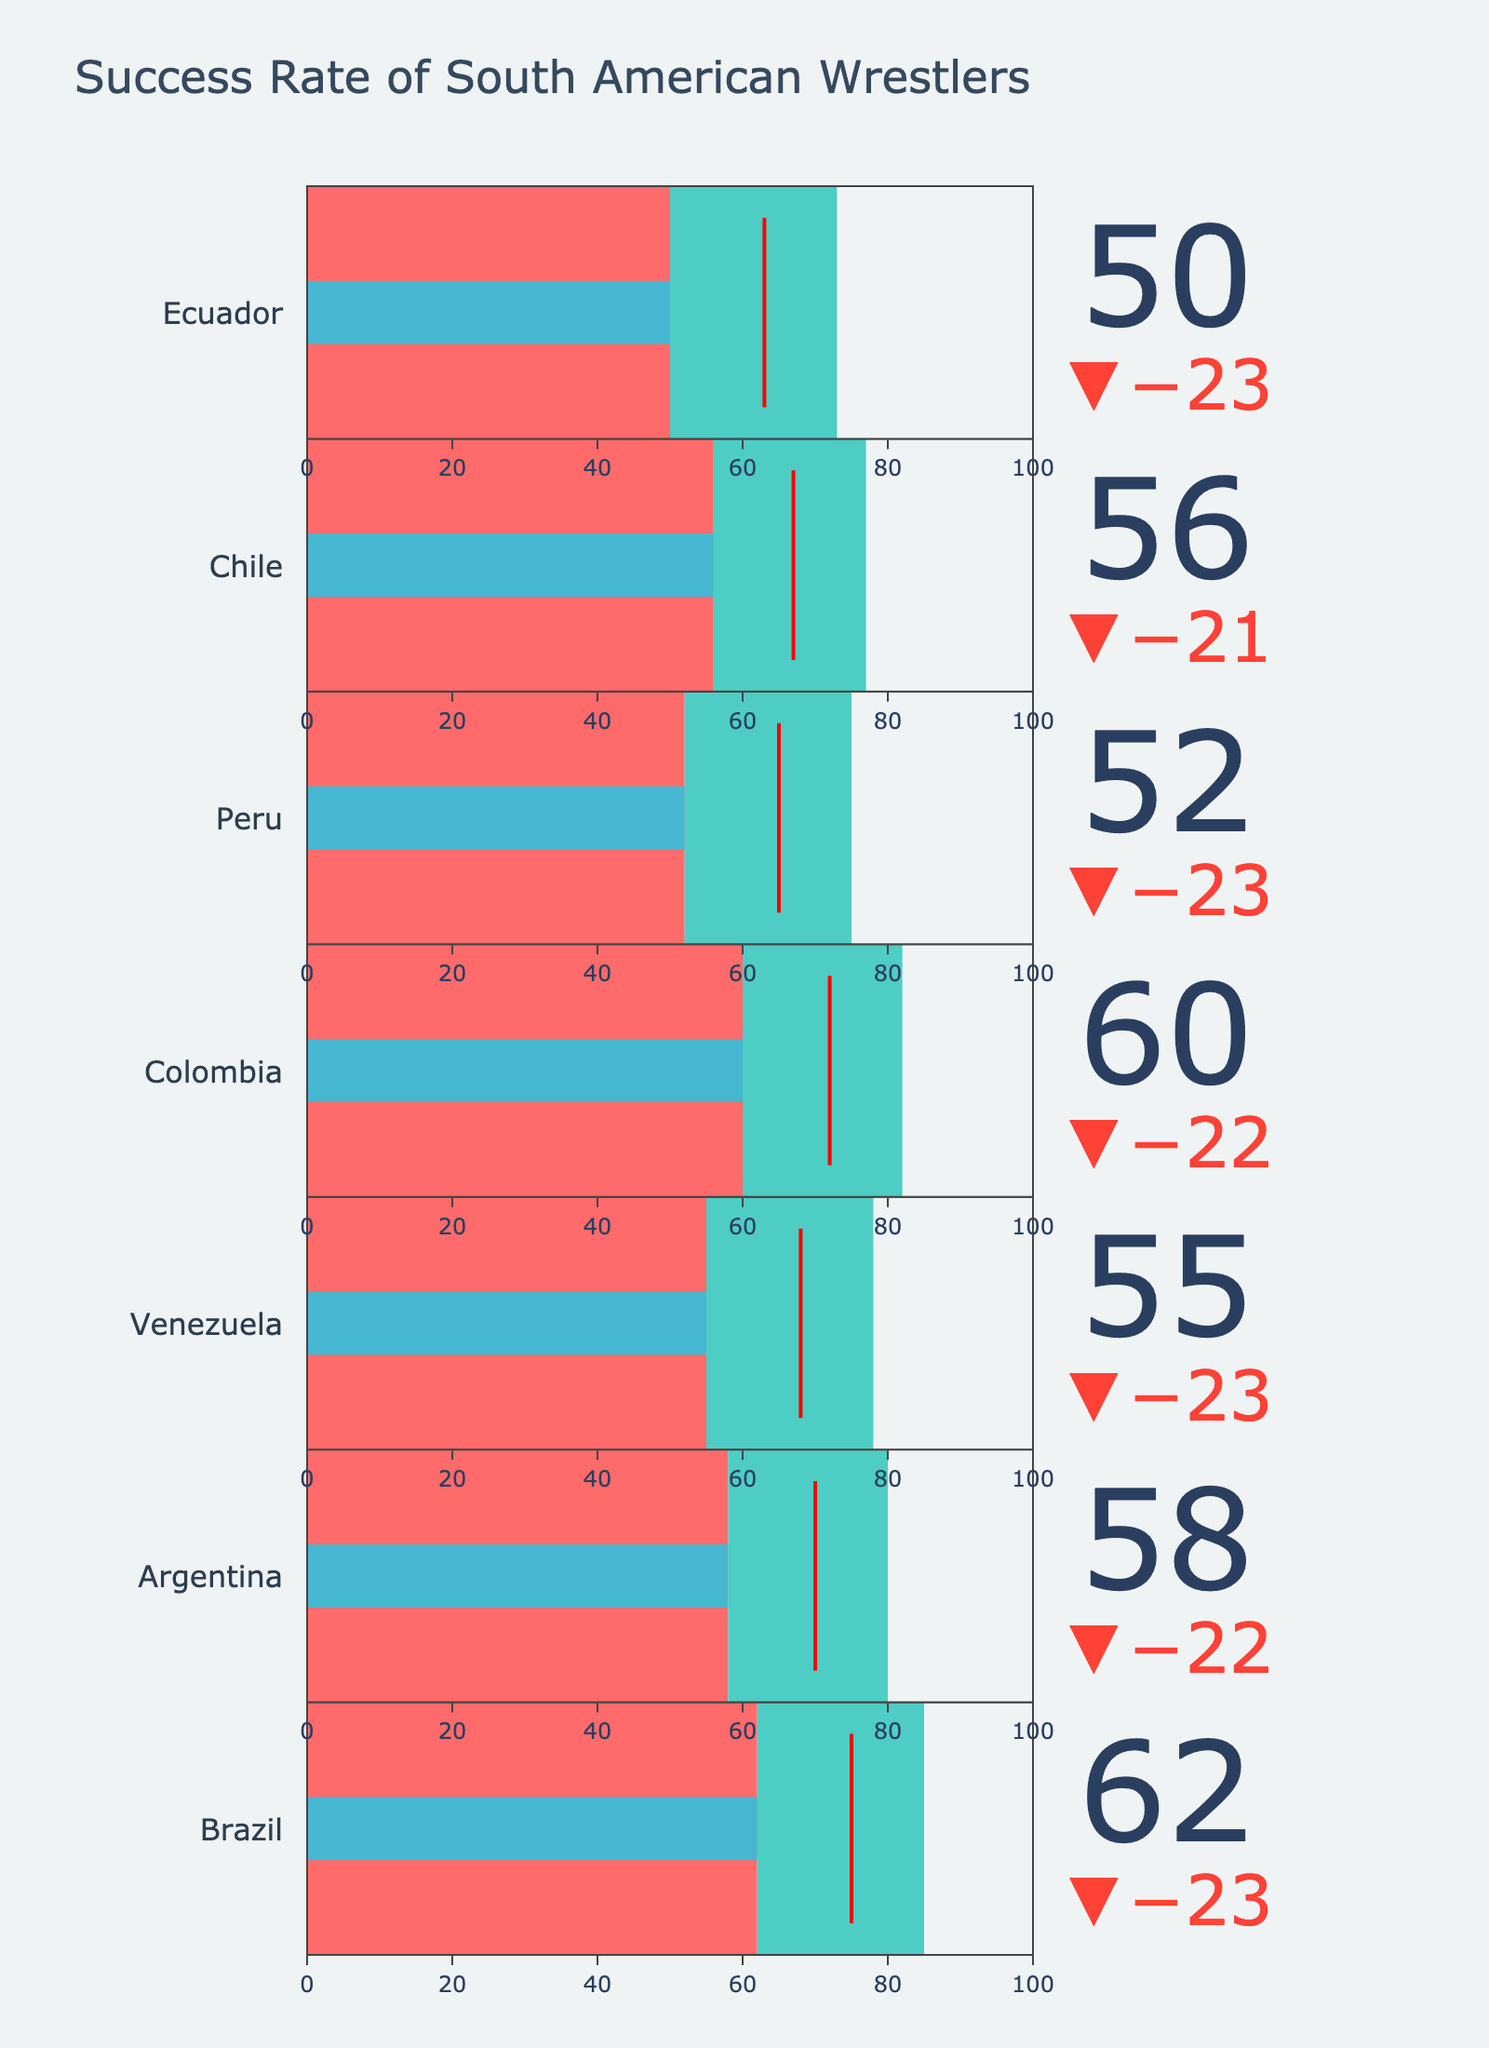What is the title of the chart? The title is usually placed at the top of the chart and is meant to give a quick idea of what the chart is about.
Answer: Success Rate of South American Wrestlers How many countries are included in the chart? Count the number of bullet charts present in the figure, each representing a country.
Answer: 7 Which country has the highest regional success rate? Compare the regional success rates indicated in the legend for each bullet chart and identify the highest one.
Answer: Brazil How does Venezuela's international success rate compare to its regional success rate? Check Venezuela’s bullet chart and compare the position of the international success rate indicator with the regional success rate threshold line.
Answer: It is lower Which country has the smallest difference between regional and international success rates? Calculate the difference for each country and find the one with the smallest value.
Answer: Chile What's the average international success rate across all countries? Sum the international success rates for all countries and divide by the number of countries. (62 + 58 + 55 + 60 + 52 + 56 + 50) / 7 = 393 / 7 = 56.14
Answer: 56.14 Identify the countries with an international success rate above their benchmark. Check each bullet chart to see if the international success rate bar extends beyond the benchmark line.
Answer: Brazil, Argentina What is the difference between Brazil's regional success rate and its benchmark? Subtract Brazil's benchmark from its regional success rate. 85 - 75 = 10
Answer: 10 Which country shows the greatest reduction in success rate when moving from regional to international tournaments? Calculate the difference between regional and international success rates for each country, and find the largest reduction. Brazil: 85-62=23, Argentina: 80-58=22, Venezuela: 79-55=24, Colombia: 82-60=22, Peru: 75-52=23, Chile: 77-56=21, Ecuador: 73-50=23
Answer: Venezuela Compare the international success rates of Colombia and Argentina. Refer to the bullet charts for Colombia and Argentina and compare the positions of their international success rate indicators.
Answer: Colombia's is higher 